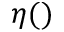Convert formula to latex. <formula><loc_0><loc_0><loc_500><loc_500>\eta ( )</formula> 